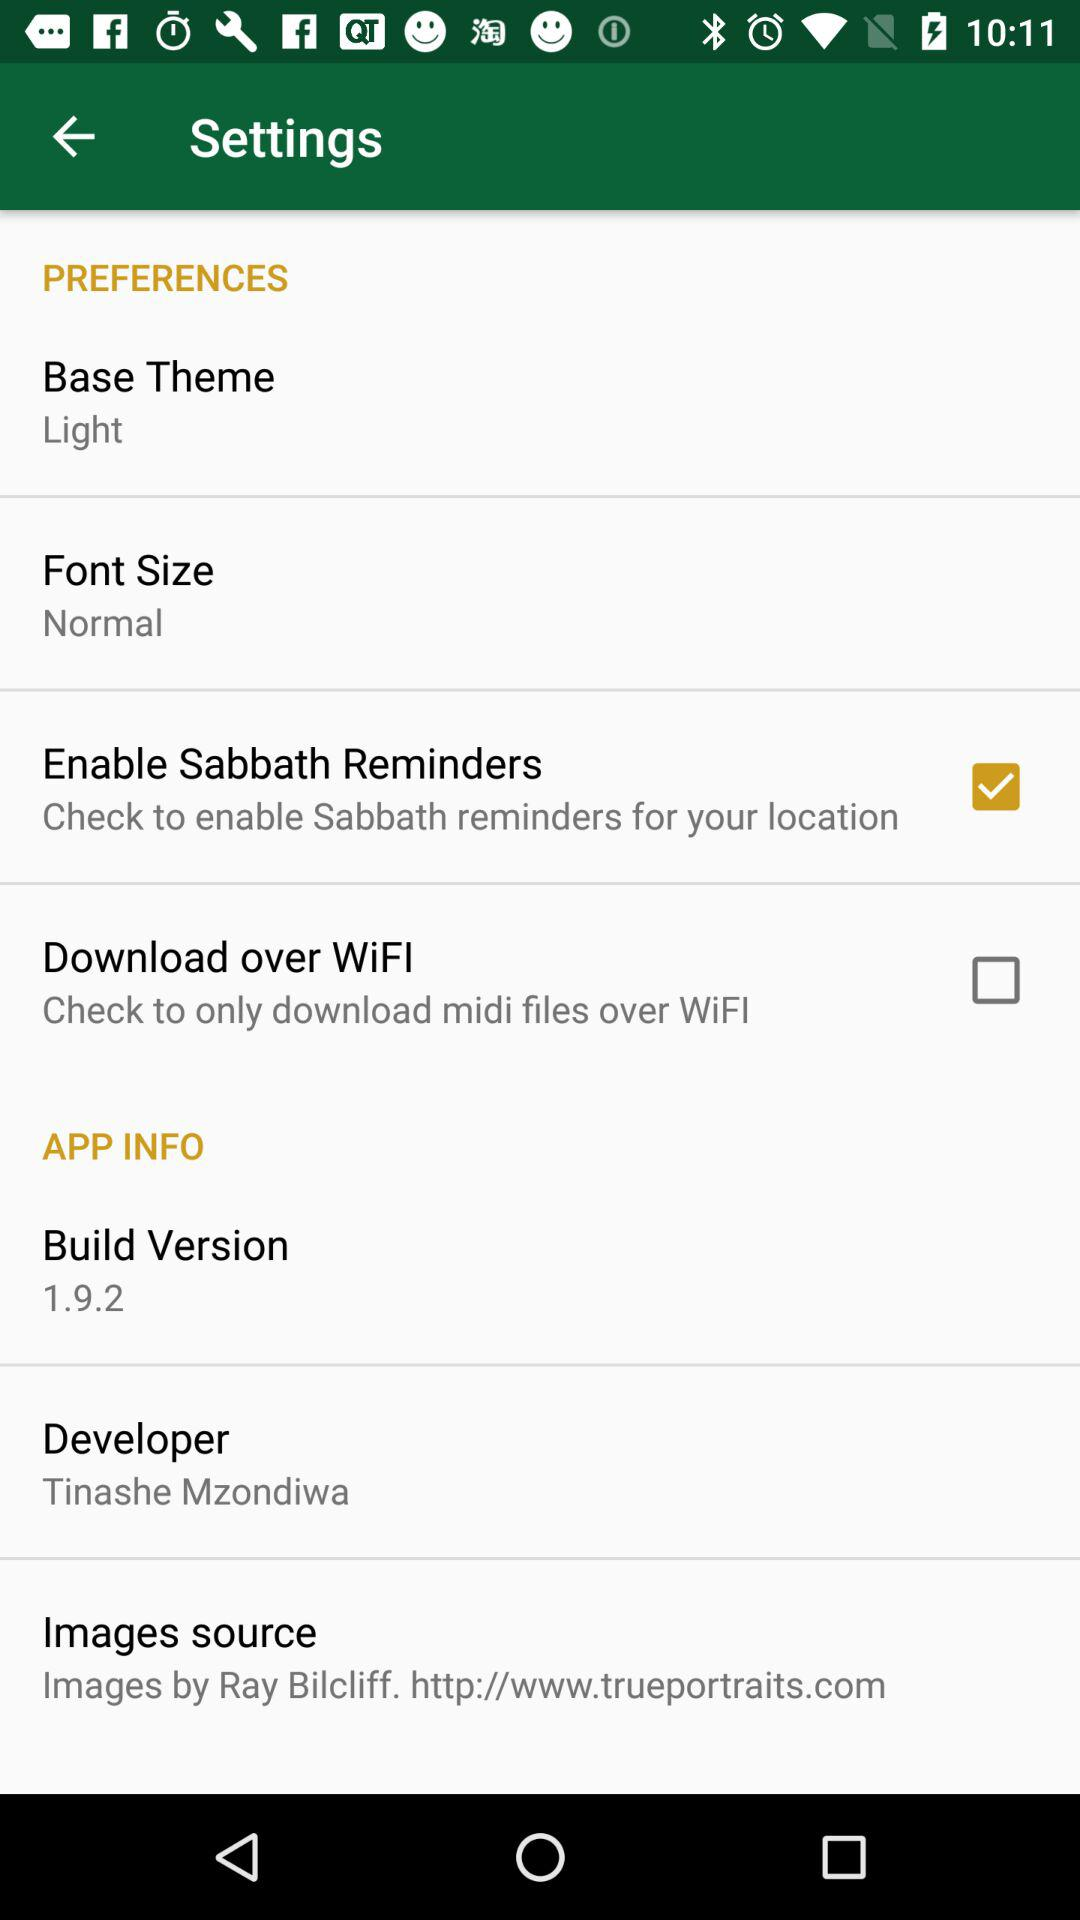Who is the developer? The developer is Tinashe Mzondiwa. 